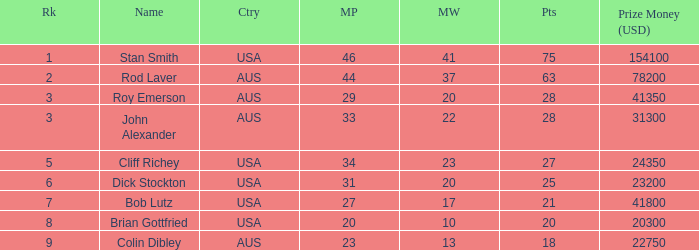How many matches did the player that played 23 matches win 13.0. 